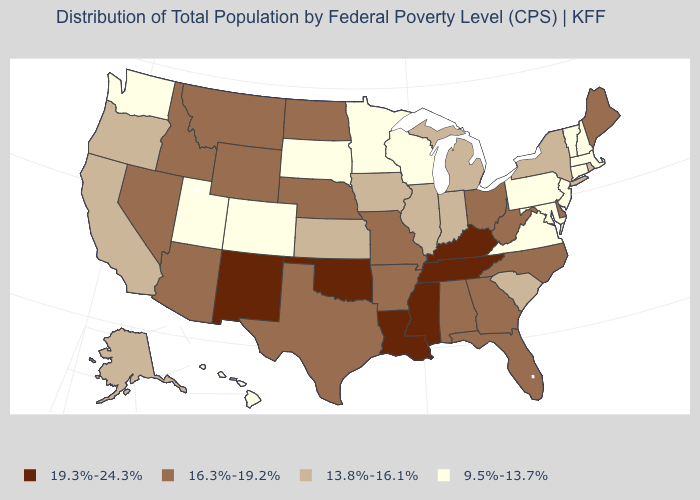Which states have the lowest value in the MidWest?
Be succinct. Minnesota, South Dakota, Wisconsin. What is the value of Maine?
Keep it brief. 16.3%-19.2%. Among the states that border Pennsylvania , does Delaware have the highest value?
Short answer required. Yes. Among the states that border Pennsylvania , which have the lowest value?
Quick response, please. Maryland, New Jersey. Name the states that have a value in the range 16.3%-19.2%?
Short answer required. Alabama, Arizona, Arkansas, Delaware, Florida, Georgia, Idaho, Maine, Missouri, Montana, Nebraska, Nevada, North Carolina, North Dakota, Ohio, Texas, West Virginia, Wyoming. Does Maine have the lowest value in the USA?
Be succinct. No. What is the value of Idaho?
Answer briefly. 16.3%-19.2%. Which states have the lowest value in the Northeast?
Answer briefly. Connecticut, Massachusetts, New Hampshire, New Jersey, Pennsylvania, Vermont. Does Connecticut have the highest value in the Northeast?
Write a very short answer. No. What is the value of Nebraska?
Be succinct. 16.3%-19.2%. Does Arizona have a lower value than New Mexico?
Answer briefly. Yes. Which states have the lowest value in the South?
Quick response, please. Maryland, Virginia. Name the states that have a value in the range 13.8%-16.1%?
Answer briefly. Alaska, California, Illinois, Indiana, Iowa, Kansas, Michigan, New York, Oregon, Rhode Island, South Carolina. Name the states that have a value in the range 9.5%-13.7%?
Concise answer only. Colorado, Connecticut, Hawaii, Maryland, Massachusetts, Minnesota, New Hampshire, New Jersey, Pennsylvania, South Dakota, Utah, Vermont, Virginia, Washington, Wisconsin. Among the states that border Alabama , does Mississippi have the highest value?
Write a very short answer. Yes. 